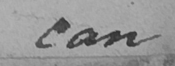Can you read and transcribe this handwriting? can 